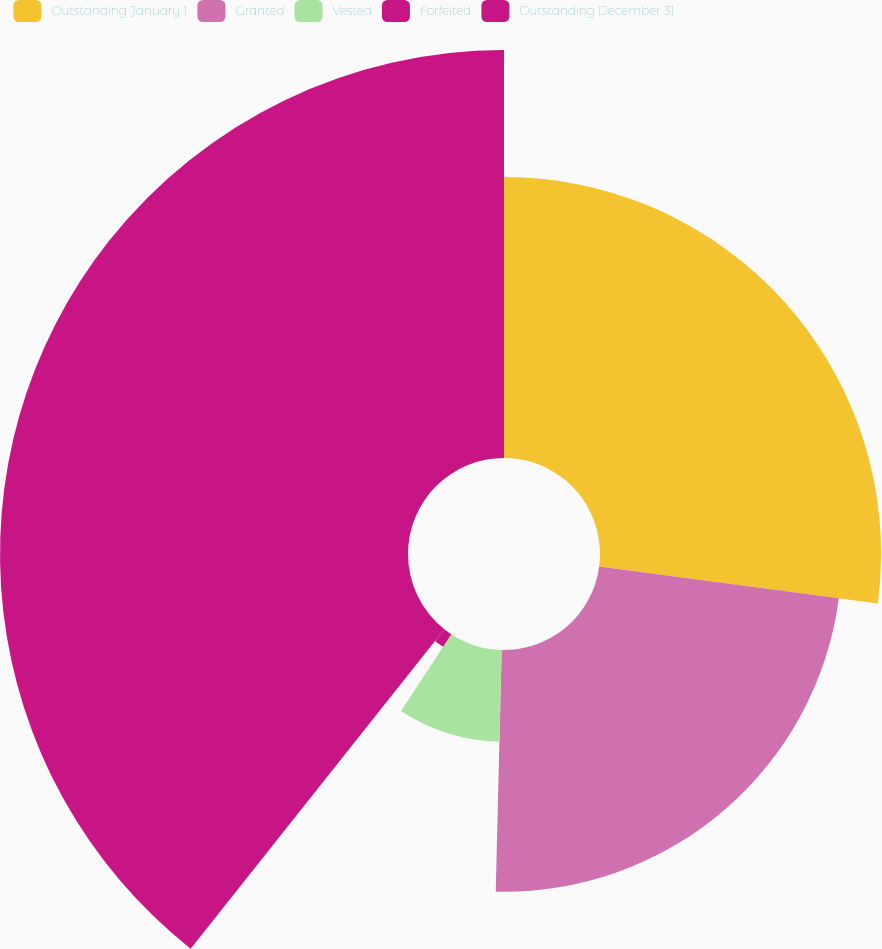<chart> <loc_0><loc_0><loc_500><loc_500><pie_chart><fcel>Outstanding January 1<fcel>Granted<fcel>Vested<fcel>Forfeited<fcel>Outstanding December 31<nl><fcel>27.09%<fcel>23.3%<fcel>8.85%<fcel>1.44%<fcel>39.32%<nl></chart> 